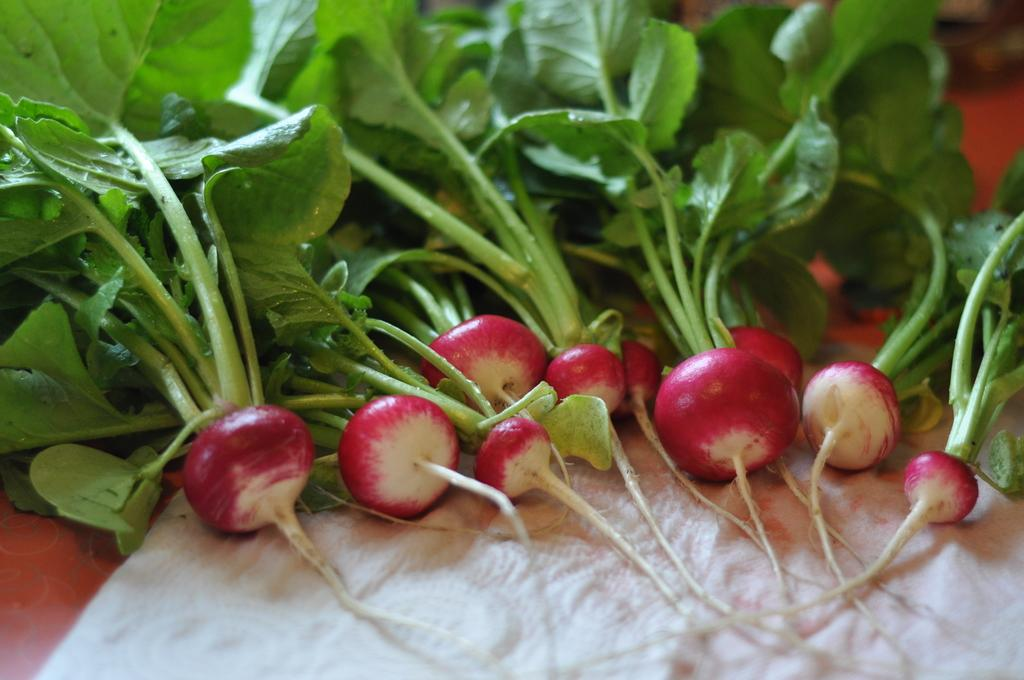What type of food items can be seen in the image? There are vegetables in the image. What other object is present in the image besides the vegetables? There is cloth in the image. Can you see a kitten playing with a straw in the image? No, there is no kitten or straw present in the image. What type of lumber is being used to support the vegetables in the image? There is no lumber present in the image; it only features vegetables and cloth. 